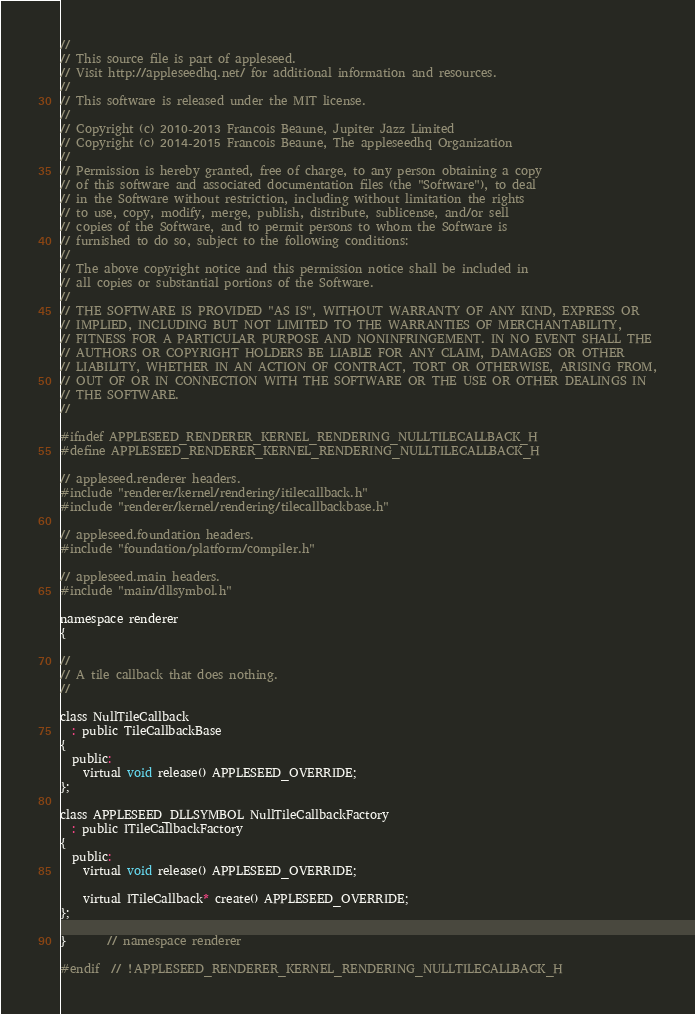<code> <loc_0><loc_0><loc_500><loc_500><_C_>
//
// This source file is part of appleseed.
// Visit http://appleseedhq.net/ for additional information and resources.
//
// This software is released under the MIT license.
//
// Copyright (c) 2010-2013 Francois Beaune, Jupiter Jazz Limited
// Copyright (c) 2014-2015 Francois Beaune, The appleseedhq Organization
//
// Permission is hereby granted, free of charge, to any person obtaining a copy
// of this software and associated documentation files (the "Software"), to deal
// in the Software without restriction, including without limitation the rights
// to use, copy, modify, merge, publish, distribute, sublicense, and/or sell
// copies of the Software, and to permit persons to whom the Software is
// furnished to do so, subject to the following conditions:
//
// The above copyright notice and this permission notice shall be included in
// all copies or substantial portions of the Software.
//
// THE SOFTWARE IS PROVIDED "AS IS", WITHOUT WARRANTY OF ANY KIND, EXPRESS OR
// IMPLIED, INCLUDING BUT NOT LIMITED TO THE WARRANTIES OF MERCHANTABILITY,
// FITNESS FOR A PARTICULAR PURPOSE AND NONINFRINGEMENT. IN NO EVENT SHALL THE
// AUTHORS OR COPYRIGHT HOLDERS BE LIABLE FOR ANY CLAIM, DAMAGES OR OTHER
// LIABILITY, WHETHER IN AN ACTION OF CONTRACT, TORT OR OTHERWISE, ARISING FROM,
// OUT OF OR IN CONNECTION WITH THE SOFTWARE OR THE USE OR OTHER DEALINGS IN
// THE SOFTWARE.
//

#ifndef APPLESEED_RENDERER_KERNEL_RENDERING_NULLTILECALLBACK_H
#define APPLESEED_RENDERER_KERNEL_RENDERING_NULLTILECALLBACK_H

// appleseed.renderer headers.
#include "renderer/kernel/rendering/itilecallback.h"
#include "renderer/kernel/rendering/tilecallbackbase.h"

// appleseed.foundation headers.
#include "foundation/platform/compiler.h"

// appleseed.main headers.
#include "main/dllsymbol.h"

namespace renderer
{

//
// A tile callback that does nothing.
//

class NullTileCallback
  : public TileCallbackBase
{
  public:
    virtual void release() APPLESEED_OVERRIDE;
};

class APPLESEED_DLLSYMBOL NullTileCallbackFactory
  : public ITileCallbackFactory
{
  public:
    virtual void release() APPLESEED_OVERRIDE;

    virtual ITileCallback* create() APPLESEED_OVERRIDE;
};

}       // namespace renderer

#endif  // !APPLESEED_RENDERER_KERNEL_RENDERING_NULLTILECALLBACK_H
</code> 